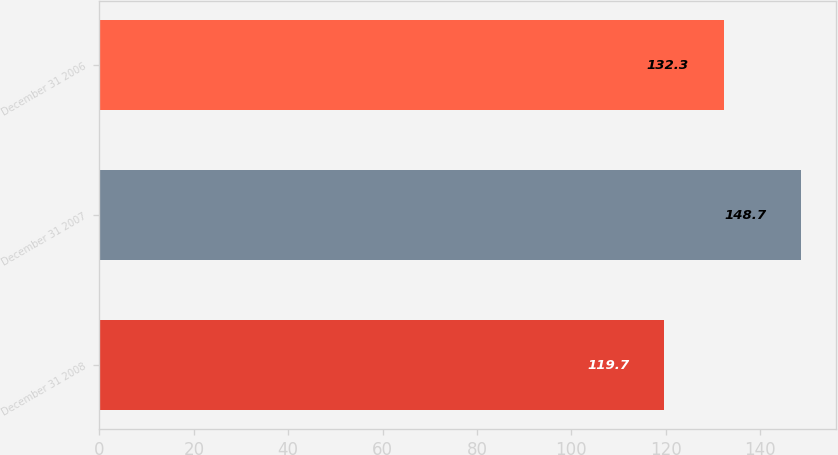Convert chart to OTSL. <chart><loc_0><loc_0><loc_500><loc_500><bar_chart><fcel>December 31 2008<fcel>December 31 2007<fcel>December 31 2006<nl><fcel>119.7<fcel>148.7<fcel>132.3<nl></chart> 